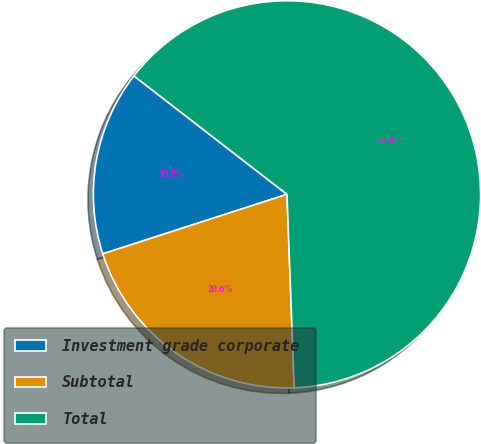Convert chart to OTSL. <chart><loc_0><loc_0><loc_500><loc_500><pie_chart><fcel>Investment grade corporate<fcel>Subtotal<fcel>Total<nl><fcel>15.46%<fcel>20.62%<fcel>63.92%<nl></chart> 